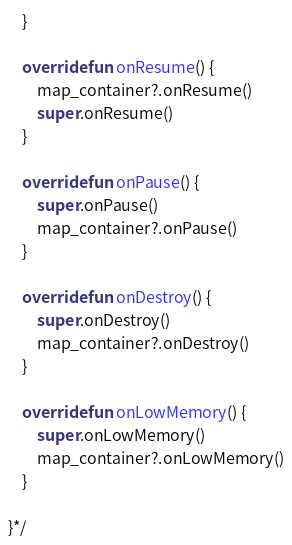<code> <loc_0><loc_0><loc_500><loc_500><_Kotlin_>    }

    override fun onResume() {
        map_container?.onResume()
        super.onResume()
    }

    override fun onPause() {
        super.onPause()
        map_container?.onPause()
    }

    override fun onDestroy() {
        super.onDestroy()
        map_container?.onDestroy()
    }

    override fun onLowMemory() {
        super.onLowMemory()
        map_container?.onLowMemory()
    }

}*/
</code> 